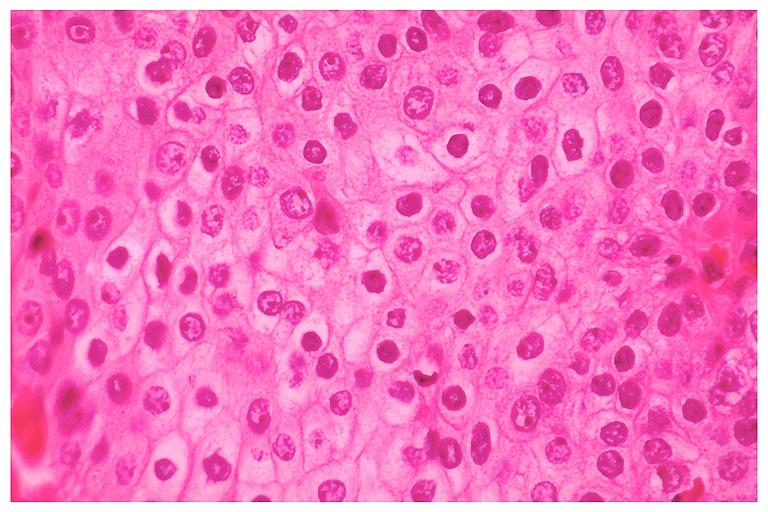where is this?
Answer the question using a single word or phrase. Oral 